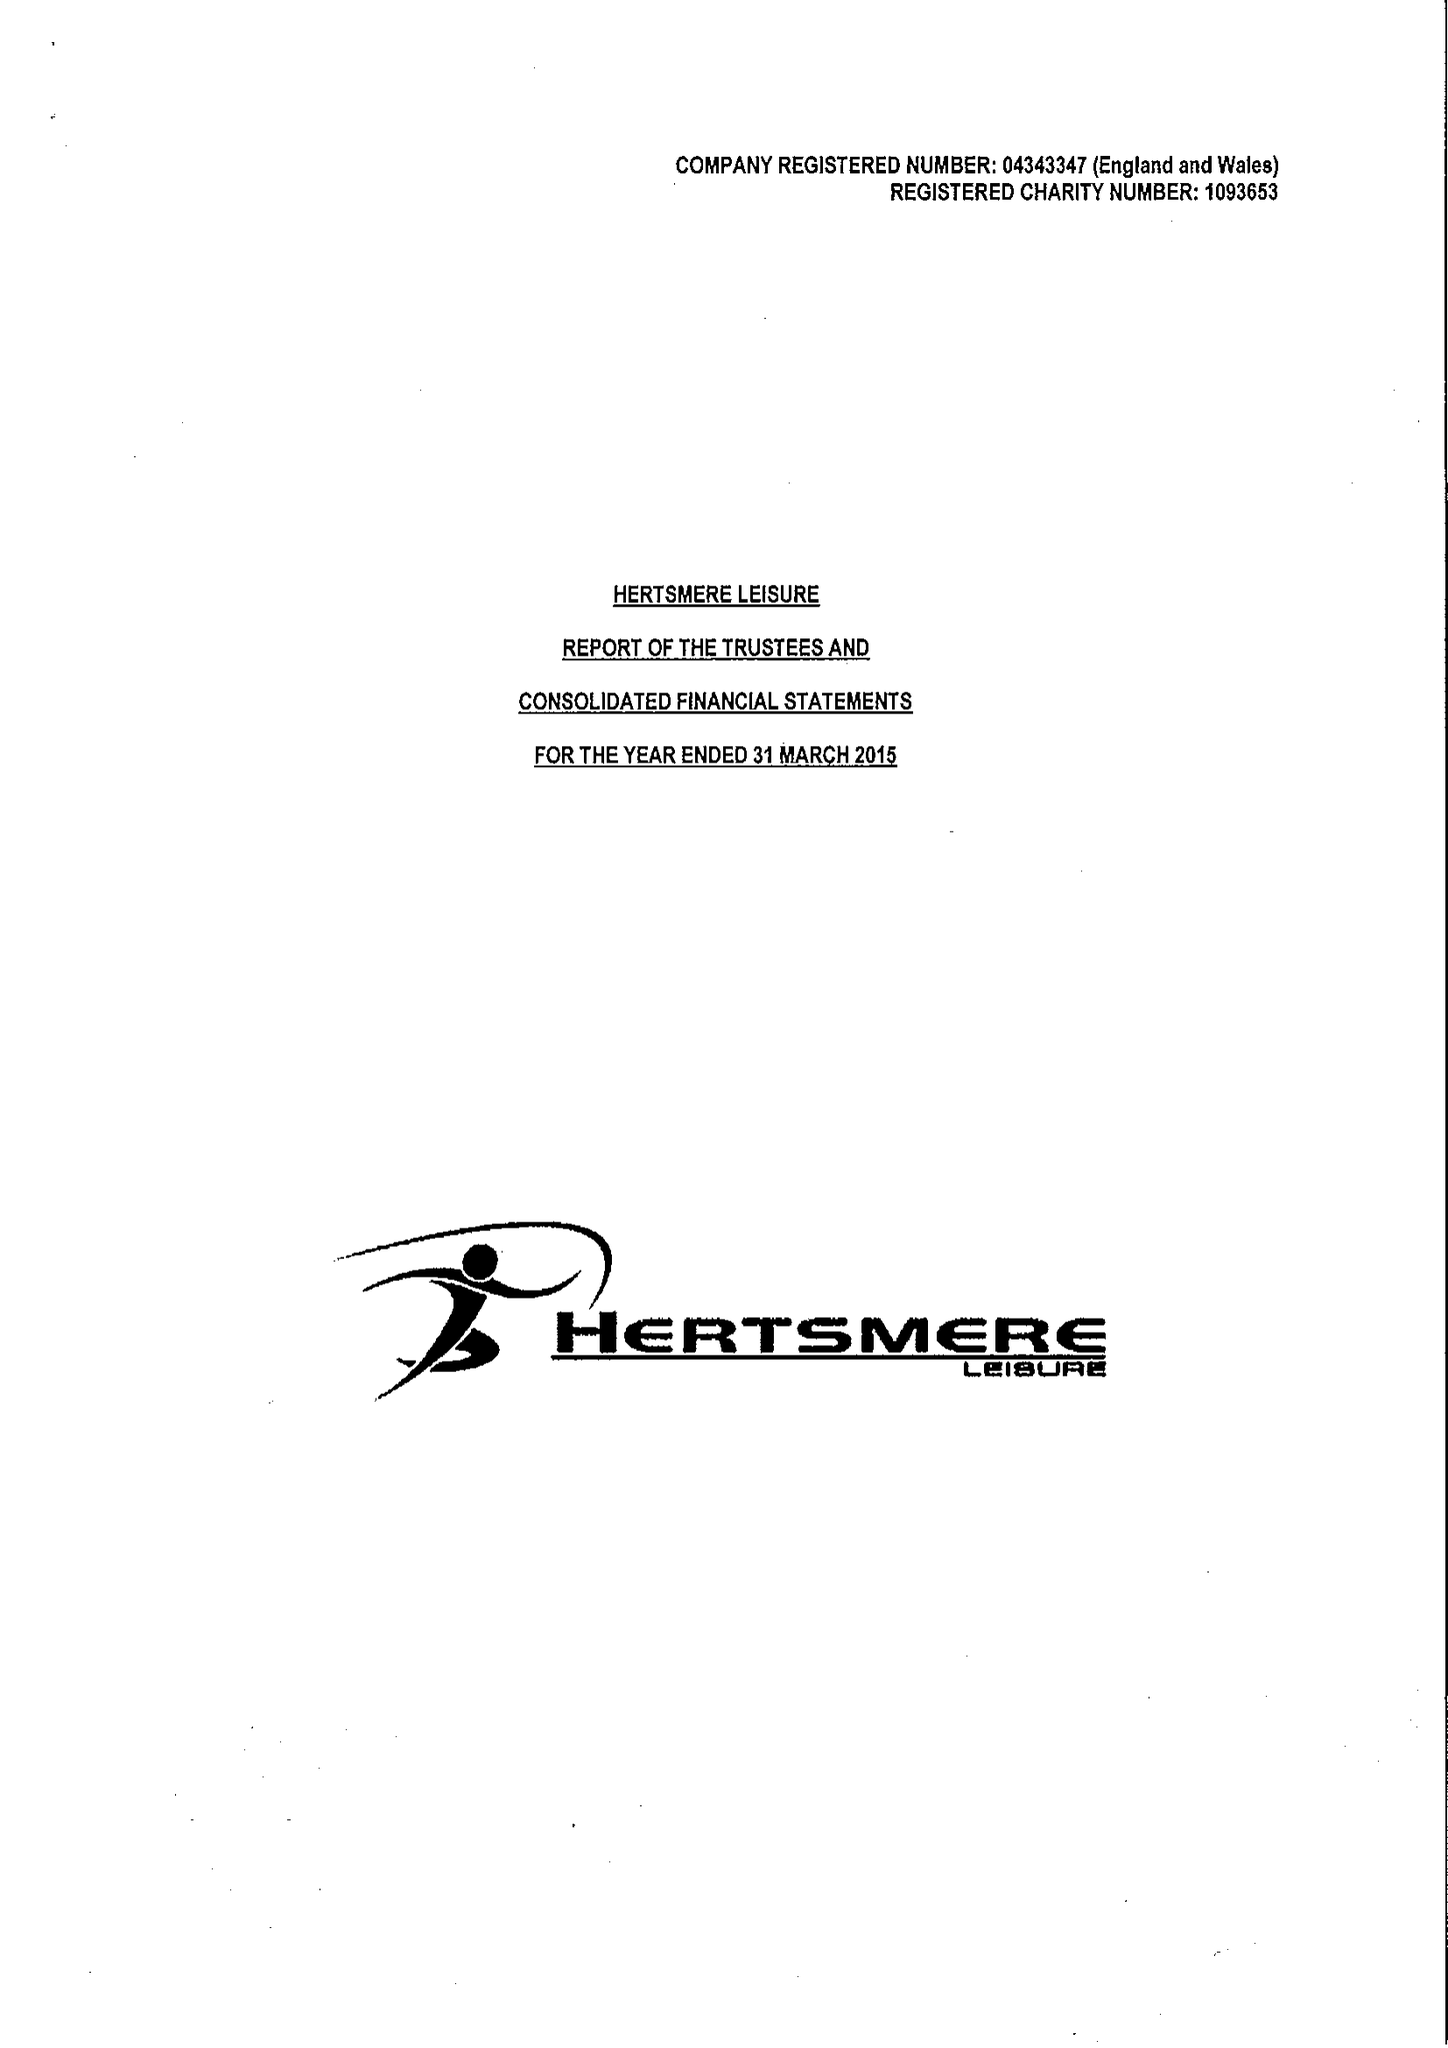What is the value for the charity_name?
Answer the question using a single word or phrase. Inspireall Leisure and Family Support Services 